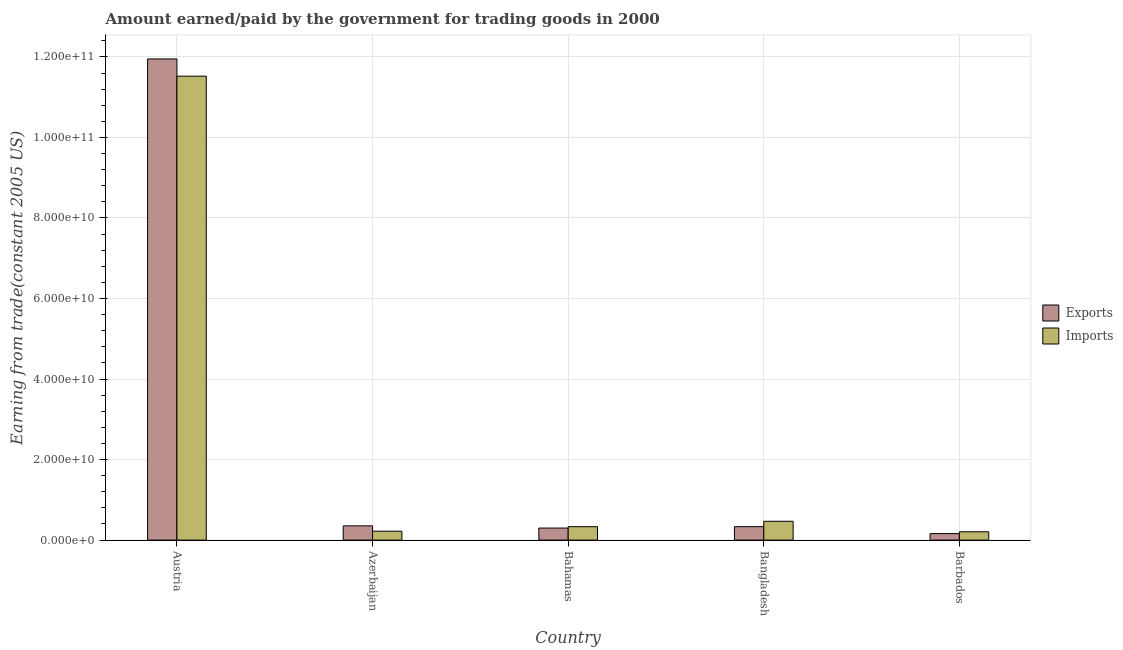How many different coloured bars are there?
Give a very brief answer. 2. How many groups of bars are there?
Your answer should be very brief. 5. Are the number of bars per tick equal to the number of legend labels?
Ensure brevity in your answer.  Yes. Are the number of bars on each tick of the X-axis equal?
Keep it short and to the point. Yes. How many bars are there on the 4th tick from the left?
Your answer should be compact. 2. How many bars are there on the 3rd tick from the right?
Your answer should be compact. 2. What is the label of the 3rd group of bars from the left?
Make the answer very short. Bahamas. In how many cases, is the number of bars for a given country not equal to the number of legend labels?
Offer a terse response. 0. What is the amount paid for imports in Barbados?
Provide a succinct answer. 2.06e+09. Across all countries, what is the maximum amount earned from exports?
Your answer should be compact. 1.19e+11. Across all countries, what is the minimum amount paid for imports?
Give a very brief answer. 2.06e+09. In which country was the amount paid for imports maximum?
Offer a very short reply. Austria. In which country was the amount paid for imports minimum?
Make the answer very short. Barbados. What is the total amount earned from exports in the graph?
Provide a succinct answer. 1.31e+11. What is the difference between the amount earned from exports in Bahamas and that in Bangladesh?
Provide a succinct answer. -3.47e+08. What is the difference between the amount earned from exports in Austria and the amount paid for imports in Barbados?
Provide a succinct answer. 1.17e+11. What is the average amount paid for imports per country?
Offer a terse response. 2.55e+1. What is the difference between the amount earned from exports and amount paid for imports in Barbados?
Your answer should be very brief. -4.47e+08. What is the ratio of the amount earned from exports in Bahamas to that in Bangladesh?
Offer a very short reply. 0.9. What is the difference between the highest and the second highest amount earned from exports?
Offer a very short reply. 1.16e+11. What is the difference between the highest and the lowest amount paid for imports?
Ensure brevity in your answer.  1.13e+11. What does the 2nd bar from the left in Austria represents?
Provide a short and direct response. Imports. What does the 2nd bar from the right in Bangladesh represents?
Provide a short and direct response. Exports. Are all the bars in the graph horizontal?
Offer a very short reply. No. What is the difference between two consecutive major ticks on the Y-axis?
Provide a short and direct response. 2.00e+1. Does the graph contain grids?
Your answer should be very brief. Yes. How many legend labels are there?
Provide a succinct answer. 2. What is the title of the graph?
Ensure brevity in your answer.  Amount earned/paid by the government for trading goods in 2000. Does "Formally registered" appear as one of the legend labels in the graph?
Your answer should be compact. No. What is the label or title of the X-axis?
Your answer should be compact. Country. What is the label or title of the Y-axis?
Provide a short and direct response. Earning from trade(constant 2005 US). What is the Earning from trade(constant 2005 US) of Exports in Austria?
Your answer should be compact. 1.19e+11. What is the Earning from trade(constant 2005 US) in Imports in Austria?
Make the answer very short. 1.15e+11. What is the Earning from trade(constant 2005 US) in Exports in Azerbaijan?
Ensure brevity in your answer.  3.54e+09. What is the Earning from trade(constant 2005 US) of Imports in Azerbaijan?
Make the answer very short. 2.21e+09. What is the Earning from trade(constant 2005 US) in Exports in Bahamas?
Offer a very short reply. 2.99e+09. What is the Earning from trade(constant 2005 US) of Imports in Bahamas?
Your answer should be compact. 3.33e+09. What is the Earning from trade(constant 2005 US) of Exports in Bangladesh?
Make the answer very short. 3.34e+09. What is the Earning from trade(constant 2005 US) in Imports in Bangladesh?
Keep it short and to the point. 4.67e+09. What is the Earning from trade(constant 2005 US) of Exports in Barbados?
Make the answer very short. 1.62e+09. What is the Earning from trade(constant 2005 US) of Imports in Barbados?
Offer a very short reply. 2.06e+09. Across all countries, what is the maximum Earning from trade(constant 2005 US) of Exports?
Make the answer very short. 1.19e+11. Across all countries, what is the maximum Earning from trade(constant 2005 US) in Imports?
Make the answer very short. 1.15e+11. Across all countries, what is the minimum Earning from trade(constant 2005 US) of Exports?
Provide a succinct answer. 1.62e+09. Across all countries, what is the minimum Earning from trade(constant 2005 US) in Imports?
Your answer should be compact. 2.06e+09. What is the total Earning from trade(constant 2005 US) in Exports in the graph?
Give a very brief answer. 1.31e+11. What is the total Earning from trade(constant 2005 US) in Imports in the graph?
Give a very brief answer. 1.27e+11. What is the difference between the Earning from trade(constant 2005 US) in Exports in Austria and that in Azerbaijan?
Provide a short and direct response. 1.16e+11. What is the difference between the Earning from trade(constant 2005 US) of Imports in Austria and that in Azerbaijan?
Offer a very short reply. 1.13e+11. What is the difference between the Earning from trade(constant 2005 US) in Exports in Austria and that in Bahamas?
Your answer should be compact. 1.17e+11. What is the difference between the Earning from trade(constant 2005 US) in Imports in Austria and that in Bahamas?
Your response must be concise. 1.12e+11. What is the difference between the Earning from trade(constant 2005 US) in Exports in Austria and that in Bangladesh?
Provide a short and direct response. 1.16e+11. What is the difference between the Earning from trade(constant 2005 US) of Imports in Austria and that in Bangladesh?
Offer a terse response. 1.11e+11. What is the difference between the Earning from trade(constant 2005 US) in Exports in Austria and that in Barbados?
Your answer should be very brief. 1.18e+11. What is the difference between the Earning from trade(constant 2005 US) of Imports in Austria and that in Barbados?
Ensure brevity in your answer.  1.13e+11. What is the difference between the Earning from trade(constant 2005 US) in Exports in Azerbaijan and that in Bahamas?
Provide a succinct answer. 5.47e+08. What is the difference between the Earning from trade(constant 2005 US) of Imports in Azerbaijan and that in Bahamas?
Ensure brevity in your answer.  -1.12e+09. What is the difference between the Earning from trade(constant 2005 US) of Exports in Azerbaijan and that in Bangladesh?
Ensure brevity in your answer.  2.00e+08. What is the difference between the Earning from trade(constant 2005 US) of Imports in Azerbaijan and that in Bangladesh?
Give a very brief answer. -2.46e+09. What is the difference between the Earning from trade(constant 2005 US) of Exports in Azerbaijan and that in Barbados?
Your answer should be compact. 1.92e+09. What is the difference between the Earning from trade(constant 2005 US) of Imports in Azerbaijan and that in Barbados?
Make the answer very short. 1.47e+08. What is the difference between the Earning from trade(constant 2005 US) in Exports in Bahamas and that in Bangladesh?
Your answer should be compact. -3.47e+08. What is the difference between the Earning from trade(constant 2005 US) of Imports in Bahamas and that in Bangladesh?
Offer a very short reply. -1.34e+09. What is the difference between the Earning from trade(constant 2005 US) of Exports in Bahamas and that in Barbados?
Ensure brevity in your answer.  1.38e+09. What is the difference between the Earning from trade(constant 2005 US) of Imports in Bahamas and that in Barbados?
Offer a terse response. 1.27e+09. What is the difference between the Earning from trade(constant 2005 US) in Exports in Bangladesh and that in Barbados?
Provide a short and direct response. 1.72e+09. What is the difference between the Earning from trade(constant 2005 US) in Imports in Bangladesh and that in Barbados?
Provide a short and direct response. 2.61e+09. What is the difference between the Earning from trade(constant 2005 US) in Exports in Austria and the Earning from trade(constant 2005 US) in Imports in Azerbaijan?
Offer a very short reply. 1.17e+11. What is the difference between the Earning from trade(constant 2005 US) of Exports in Austria and the Earning from trade(constant 2005 US) of Imports in Bahamas?
Keep it short and to the point. 1.16e+11. What is the difference between the Earning from trade(constant 2005 US) of Exports in Austria and the Earning from trade(constant 2005 US) of Imports in Bangladesh?
Offer a very short reply. 1.15e+11. What is the difference between the Earning from trade(constant 2005 US) of Exports in Austria and the Earning from trade(constant 2005 US) of Imports in Barbados?
Make the answer very short. 1.17e+11. What is the difference between the Earning from trade(constant 2005 US) in Exports in Azerbaijan and the Earning from trade(constant 2005 US) in Imports in Bahamas?
Your answer should be very brief. 2.08e+08. What is the difference between the Earning from trade(constant 2005 US) of Exports in Azerbaijan and the Earning from trade(constant 2005 US) of Imports in Bangladesh?
Offer a very short reply. -1.13e+09. What is the difference between the Earning from trade(constant 2005 US) in Exports in Azerbaijan and the Earning from trade(constant 2005 US) in Imports in Barbados?
Give a very brief answer. 1.48e+09. What is the difference between the Earning from trade(constant 2005 US) of Exports in Bahamas and the Earning from trade(constant 2005 US) of Imports in Bangladesh?
Ensure brevity in your answer.  -1.68e+09. What is the difference between the Earning from trade(constant 2005 US) of Exports in Bahamas and the Earning from trade(constant 2005 US) of Imports in Barbados?
Provide a succinct answer. 9.30e+08. What is the difference between the Earning from trade(constant 2005 US) of Exports in Bangladesh and the Earning from trade(constant 2005 US) of Imports in Barbados?
Keep it short and to the point. 1.28e+09. What is the average Earning from trade(constant 2005 US) in Exports per country?
Keep it short and to the point. 2.62e+1. What is the average Earning from trade(constant 2005 US) of Imports per country?
Your answer should be compact. 2.55e+1. What is the difference between the Earning from trade(constant 2005 US) of Exports and Earning from trade(constant 2005 US) of Imports in Austria?
Give a very brief answer. 4.28e+09. What is the difference between the Earning from trade(constant 2005 US) of Exports and Earning from trade(constant 2005 US) of Imports in Azerbaijan?
Make the answer very short. 1.33e+09. What is the difference between the Earning from trade(constant 2005 US) in Exports and Earning from trade(constant 2005 US) in Imports in Bahamas?
Your response must be concise. -3.39e+08. What is the difference between the Earning from trade(constant 2005 US) of Exports and Earning from trade(constant 2005 US) of Imports in Bangladesh?
Offer a very short reply. -1.33e+09. What is the difference between the Earning from trade(constant 2005 US) in Exports and Earning from trade(constant 2005 US) in Imports in Barbados?
Provide a succinct answer. -4.47e+08. What is the ratio of the Earning from trade(constant 2005 US) of Exports in Austria to that in Azerbaijan?
Provide a succinct answer. 33.76. What is the ratio of the Earning from trade(constant 2005 US) of Imports in Austria to that in Azerbaijan?
Provide a short and direct response. 52.15. What is the ratio of the Earning from trade(constant 2005 US) in Exports in Austria to that in Bahamas?
Provide a succinct answer. 39.93. What is the ratio of the Earning from trade(constant 2005 US) in Imports in Austria to that in Bahamas?
Make the answer very short. 34.59. What is the ratio of the Earning from trade(constant 2005 US) of Exports in Austria to that in Bangladesh?
Your response must be concise. 35.79. What is the ratio of the Earning from trade(constant 2005 US) of Imports in Austria to that in Bangladesh?
Offer a very short reply. 24.66. What is the ratio of the Earning from trade(constant 2005 US) of Exports in Austria to that in Barbados?
Provide a short and direct response. 73.96. What is the ratio of the Earning from trade(constant 2005 US) of Imports in Austria to that in Barbados?
Keep it short and to the point. 55.86. What is the ratio of the Earning from trade(constant 2005 US) in Exports in Azerbaijan to that in Bahamas?
Provide a short and direct response. 1.18. What is the ratio of the Earning from trade(constant 2005 US) in Imports in Azerbaijan to that in Bahamas?
Provide a succinct answer. 0.66. What is the ratio of the Earning from trade(constant 2005 US) in Exports in Azerbaijan to that in Bangladesh?
Ensure brevity in your answer.  1.06. What is the ratio of the Earning from trade(constant 2005 US) in Imports in Azerbaijan to that in Bangladesh?
Offer a very short reply. 0.47. What is the ratio of the Earning from trade(constant 2005 US) of Exports in Azerbaijan to that in Barbados?
Offer a terse response. 2.19. What is the ratio of the Earning from trade(constant 2005 US) of Imports in Azerbaijan to that in Barbados?
Provide a succinct answer. 1.07. What is the ratio of the Earning from trade(constant 2005 US) in Exports in Bahamas to that in Bangladesh?
Your answer should be very brief. 0.9. What is the ratio of the Earning from trade(constant 2005 US) of Imports in Bahamas to that in Bangladesh?
Provide a succinct answer. 0.71. What is the ratio of the Earning from trade(constant 2005 US) in Exports in Bahamas to that in Barbados?
Your answer should be compact. 1.85. What is the ratio of the Earning from trade(constant 2005 US) in Imports in Bahamas to that in Barbados?
Ensure brevity in your answer.  1.61. What is the ratio of the Earning from trade(constant 2005 US) of Exports in Bangladesh to that in Barbados?
Your answer should be compact. 2.07. What is the ratio of the Earning from trade(constant 2005 US) in Imports in Bangladesh to that in Barbados?
Your response must be concise. 2.27. What is the difference between the highest and the second highest Earning from trade(constant 2005 US) in Exports?
Your answer should be compact. 1.16e+11. What is the difference between the highest and the second highest Earning from trade(constant 2005 US) in Imports?
Provide a short and direct response. 1.11e+11. What is the difference between the highest and the lowest Earning from trade(constant 2005 US) of Exports?
Make the answer very short. 1.18e+11. What is the difference between the highest and the lowest Earning from trade(constant 2005 US) of Imports?
Offer a very short reply. 1.13e+11. 